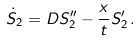<formula> <loc_0><loc_0><loc_500><loc_500>\dot { S } _ { 2 } & = D S _ { 2 } ^ { \prime \prime } - \frac { x } { t } S _ { 2 } ^ { \prime } \, .</formula> 